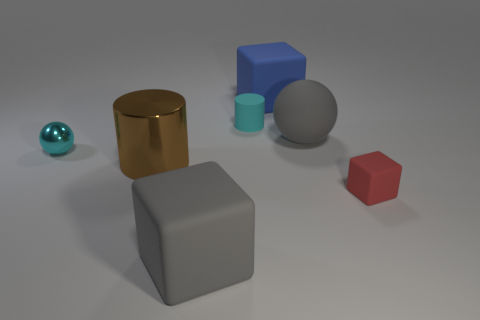Is the number of cyan cylinders on the right side of the small matte block greater than the number of small yellow things?
Offer a terse response. No. There is a cylinder that is left of the large matte block in front of the large brown cylinder; what color is it?
Make the answer very short. Brown. How many things are either large rubber cubes that are behind the big brown object or tiny rubber things on the right side of the blue matte thing?
Provide a short and direct response. 2. The matte sphere is what color?
Keep it short and to the point. Gray. How many other blocks have the same material as the big blue block?
Keep it short and to the point. 2. Is the number of cyan cylinders greater than the number of big green metal balls?
Your answer should be very brief. Yes. What number of shiny cylinders are in front of the big gray rubber thing in front of the tiny red block?
Provide a short and direct response. 0. How many things are either large blue rubber cubes behind the tiny red thing or matte blocks?
Provide a short and direct response. 3. Are there any other tiny rubber objects that have the same shape as the blue matte object?
Offer a very short reply. Yes. The tiny thing that is on the right side of the small rubber thing left of the big sphere is what shape?
Your response must be concise. Cube. 